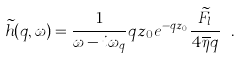Convert formula to latex. <formula><loc_0><loc_0><loc_500><loc_500>\widetilde { h } ( q , \omega ) = \frac { 1 } { \omega - i \omega _ { q } } q z _ { 0 } e ^ { - q z _ { 0 } } \frac { \widetilde { F } _ { l } } { 4 \overline { \eta } q } \ .</formula> 